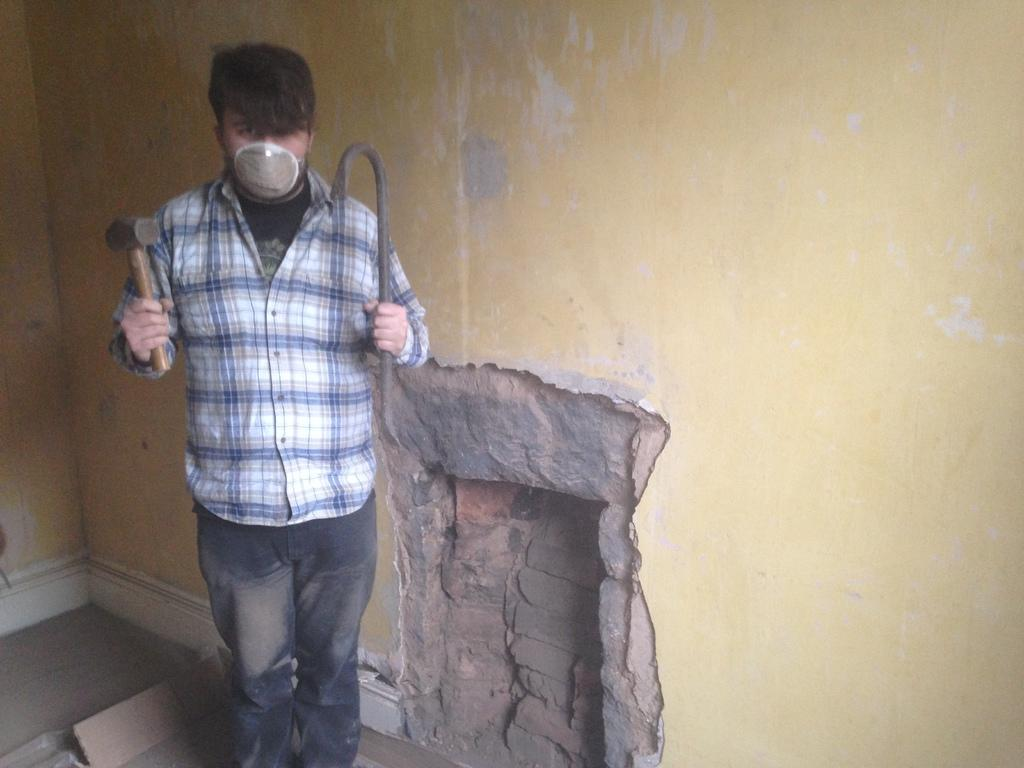Who is present in the image? There is a man in the image. What is the man wearing on his face? The man is wearing a mask on his nose. What is the man holding in one hand? The man is holding a hammer in one hand. What is the man holding in his other hand? The man is holding an object in his other hand. What can be seen in the background of the image? There is a wall in the image, and bricks are visible. How many flies are buzzing around the man's head in the image? There are no flies visible in the image. What arithmetic problem is the man trying to solve with the hammer and object in his hands? The image does not depict the man attempting to solve an arithmetic problem. What type of substance is the man applying to the wall with the hammer and object in his hands? The image does not show the man applying any substance to the wall. 